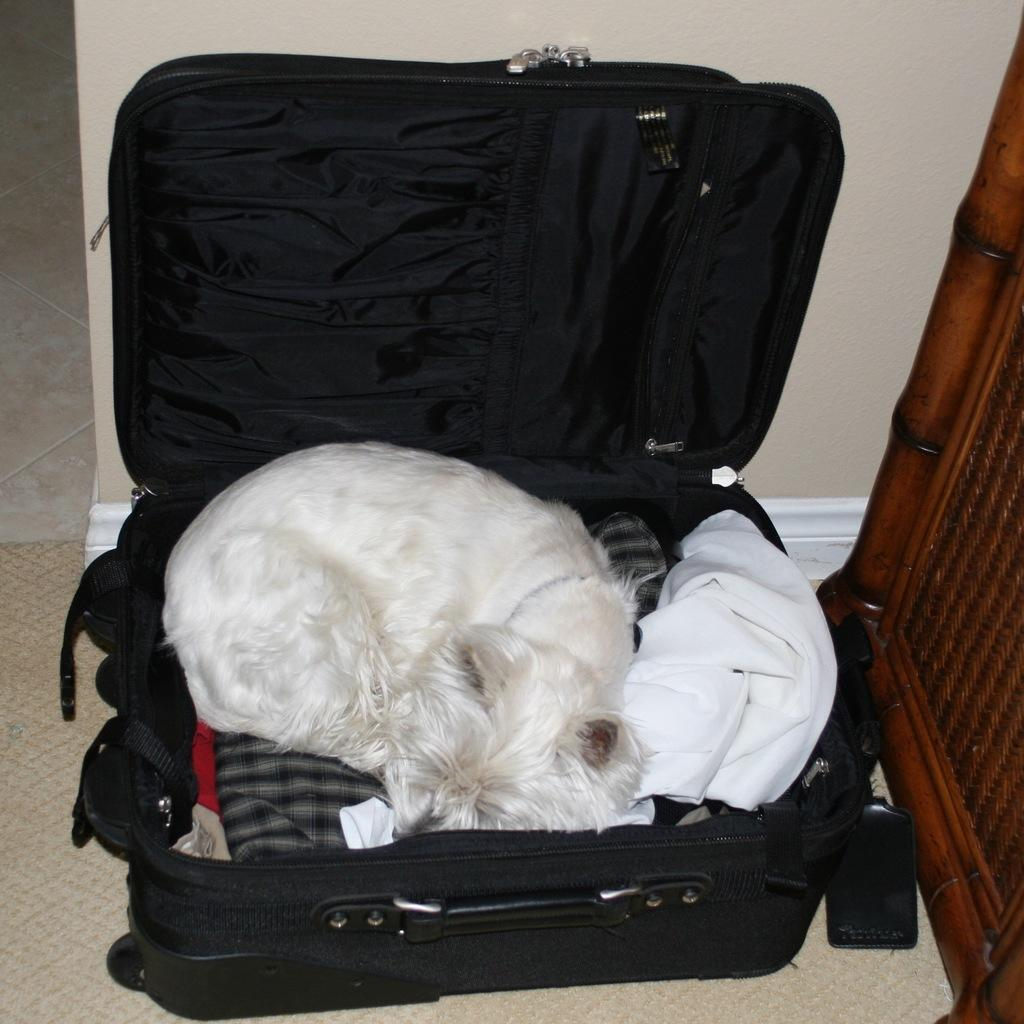What animal can be seen in the image? There is a cat in the image. What is the cat doing in the image? The cat is sleeping. Where is the cat located in the image? The cat is on clothes placed in a suitcase. What type of wall is visible in the image? There is a wooden wall in the image. What can be seen in the background of the image? There is a wall visible in the background of the image. What type of cart is being used to transport the cat in the image? There is no cart present in the image; the cat is on clothes placed in a suitcase. How does the cat's behavior compare to that of a ray in the image? There is no ray present in the image, so it is not possible to make a comparison. 